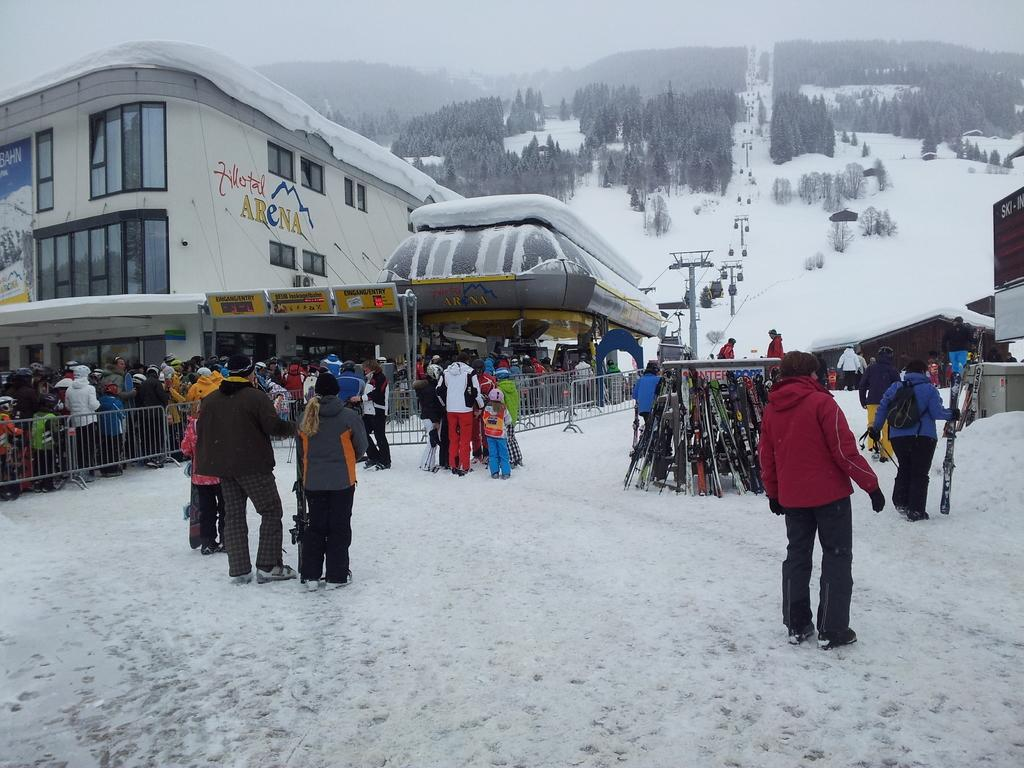What is the setting of the image? The image shows an outside view. Can you describe the people in the image? There is a group of people in the image, and they are wearing clothes. What is the location of the people in the image? The people are standing in front of a building. What additional feature can be seen in the image? There is a ropeway visible in the image. What type of vegetation is present at the top of the image? There are trees at the top of the image. What time of day is it in the image, and how does the pollution affect the visibility? The provided facts do not mention the time of day or the presence of pollution, so we cannot answer these questions based on the image. Can you tell me how many buckets are being used by the people in the image? There are no buckets visible in the image. 